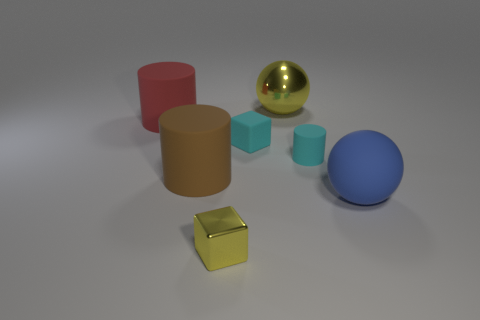There is a big metal thing that is the same color as the metal block; what shape is it?
Ensure brevity in your answer.  Sphere. Are the large blue thing and the small cyan thing to the right of the tiny cyan matte block made of the same material?
Offer a very short reply. Yes. What number of objects are large yellow balls or small shiny objects?
Give a very brief answer. 2. Is there a small brown cylinder?
Your answer should be very brief. No. The large matte object that is on the right side of the cyan rubber thing to the right of the large yellow metal ball is what shape?
Your answer should be very brief. Sphere. How many objects are either small things that are behind the tiny yellow thing or matte cylinders left of the small yellow block?
Offer a terse response. 4. What material is the yellow object that is the same size as the cyan matte block?
Give a very brief answer. Metal. What color is the small matte cylinder?
Your answer should be very brief. Cyan. What is the material of the large object that is right of the big red matte object and behind the big brown matte object?
Keep it short and to the point. Metal. There is a big rubber cylinder in front of the big cylinder that is behind the brown matte cylinder; is there a shiny thing that is in front of it?
Your answer should be very brief. Yes. 